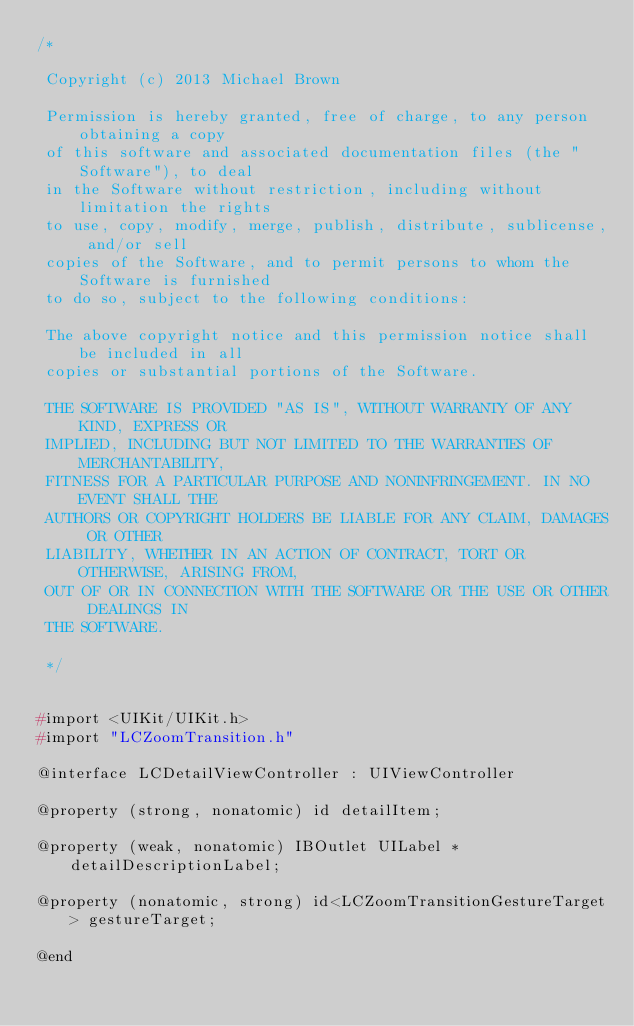<code> <loc_0><loc_0><loc_500><loc_500><_C_>/*
 
 Copyright (c) 2013 Michael Brown 
 
 Permission is hereby granted, free of charge, to any person obtaining a copy
 of this software and associated documentation files (the "Software"), to deal
 in the Software without restriction, including without limitation the rights
 to use, copy, modify, merge, publish, distribute, sublicense, and/or sell
 copies of the Software, and to permit persons to whom the Software is furnished
 to do so, subject to the following conditions:
 
 The above copyright notice and this permission notice shall be included in all
 copies or substantial portions of the Software.
 
 THE SOFTWARE IS PROVIDED "AS IS", WITHOUT WARRANTY OF ANY KIND, EXPRESS OR
 IMPLIED, INCLUDING BUT NOT LIMITED TO THE WARRANTIES OF MERCHANTABILITY,
 FITNESS FOR A PARTICULAR PURPOSE AND NONINFRINGEMENT. IN NO EVENT SHALL THE
 AUTHORS OR COPYRIGHT HOLDERS BE LIABLE FOR ANY CLAIM, DAMAGES OR OTHER
 LIABILITY, WHETHER IN AN ACTION OF CONTRACT, TORT OR OTHERWISE, ARISING FROM,
 OUT OF OR IN CONNECTION WITH THE SOFTWARE OR THE USE OR OTHER DEALINGS IN
 THE SOFTWARE.
 
 */


#import <UIKit/UIKit.h>
#import "LCZoomTransition.h"

@interface LCDetailViewController : UIViewController

@property (strong, nonatomic) id detailItem;

@property (weak, nonatomic) IBOutlet UILabel *detailDescriptionLabel;

@property (nonatomic, strong) id<LCZoomTransitionGestureTarget> gestureTarget;

@end
</code> 